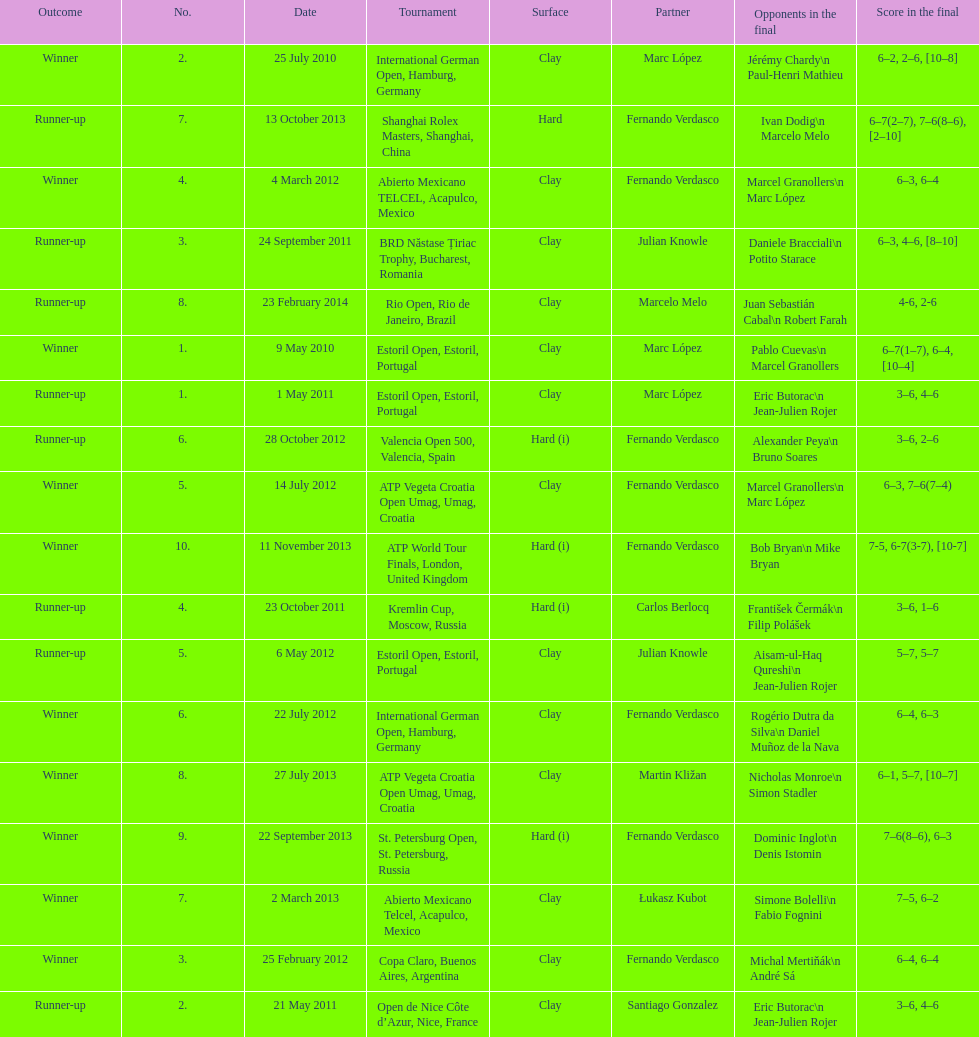Which tournament has the largest number? ATP World Tour Finals. Give me the full table as a dictionary. {'header': ['Outcome', 'No.', 'Date', 'Tournament', 'Surface', 'Partner', 'Opponents in the final', 'Score in the final'], 'rows': [['Winner', '2.', '25 July 2010', 'International German Open, Hamburg, Germany', 'Clay', 'Marc López', 'Jérémy Chardy\\n Paul-Henri Mathieu', '6–2, 2–6, [10–8]'], ['Runner-up', '7.', '13 October 2013', 'Shanghai Rolex Masters, Shanghai, China', 'Hard', 'Fernando Verdasco', 'Ivan Dodig\\n Marcelo Melo', '6–7(2–7), 7–6(8–6), [2–10]'], ['Winner', '4.', '4 March 2012', 'Abierto Mexicano TELCEL, Acapulco, Mexico', 'Clay', 'Fernando Verdasco', 'Marcel Granollers\\n Marc López', '6–3, 6–4'], ['Runner-up', '3.', '24 September 2011', 'BRD Năstase Țiriac Trophy, Bucharest, Romania', 'Clay', 'Julian Knowle', 'Daniele Bracciali\\n Potito Starace', '6–3, 4–6, [8–10]'], ['Runner-up', '8.', '23 February 2014', 'Rio Open, Rio de Janeiro, Brazil', 'Clay', 'Marcelo Melo', 'Juan Sebastián Cabal\\n Robert Farah', '4-6, 2-6'], ['Winner', '1.', '9 May 2010', 'Estoril Open, Estoril, Portugal', 'Clay', 'Marc López', 'Pablo Cuevas\\n Marcel Granollers', '6–7(1–7), 6–4, [10–4]'], ['Runner-up', '1.', '1 May 2011', 'Estoril Open, Estoril, Portugal', 'Clay', 'Marc López', 'Eric Butorac\\n Jean-Julien Rojer', '3–6, 4–6'], ['Runner-up', '6.', '28 October 2012', 'Valencia Open 500, Valencia, Spain', 'Hard (i)', 'Fernando Verdasco', 'Alexander Peya\\n Bruno Soares', '3–6, 2–6'], ['Winner', '5.', '14 July 2012', 'ATP Vegeta Croatia Open Umag, Umag, Croatia', 'Clay', 'Fernando Verdasco', 'Marcel Granollers\\n Marc López', '6–3, 7–6(7–4)'], ['Winner', '10.', '11 November 2013', 'ATP World Tour Finals, London, United Kingdom', 'Hard (i)', 'Fernando Verdasco', 'Bob Bryan\\n Mike Bryan', '7-5, 6-7(3-7), [10-7]'], ['Runner-up', '4.', '23 October 2011', 'Kremlin Cup, Moscow, Russia', 'Hard (i)', 'Carlos Berlocq', 'František Čermák\\n Filip Polášek', '3–6, 1–6'], ['Runner-up', '5.', '6 May 2012', 'Estoril Open, Estoril, Portugal', 'Clay', 'Julian Knowle', 'Aisam-ul-Haq Qureshi\\n Jean-Julien Rojer', '5–7, 5–7'], ['Winner', '6.', '22 July 2012', 'International German Open, Hamburg, Germany', 'Clay', 'Fernando Verdasco', 'Rogério Dutra da Silva\\n Daniel Muñoz de la Nava', '6–4, 6–3'], ['Winner', '8.', '27 July 2013', 'ATP Vegeta Croatia Open Umag, Umag, Croatia', 'Clay', 'Martin Kližan', 'Nicholas Monroe\\n Simon Stadler', '6–1, 5–7, [10–7]'], ['Winner', '9.', '22 September 2013', 'St. Petersburg Open, St. Petersburg, Russia', 'Hard (i)', 'Fernando Verdasco', 'Dominic Inglot\\n Denis Istomin', '7–6(8–6), 6–3'], ['Winner', '7.', '2 March 2013', 'Abierto Mexicano Telcel, Acapulco, Mexico', 'Clay', 'Łukasz Kubot', 'Simone Bolelli\\n Fabio Fognini', '7–5, 6–2'], ['Winner', '3.', '25 February 2012', 'Copa Claro, Buenos Aires, Argentina', 'Clay', 'Fernando Verdasco', 'Michal Mertiňák\\n André Sá', '6–4, 6–4'], ['Runner-up', '2.', '21 May 2011', 'Open de Nice Côte d’Azur, Nice, France', 'Clay', 'Santiago Gonzalez', 'Eric Butorac\\n Jean-Julien Rojer', '3–6, 4–6']]} 